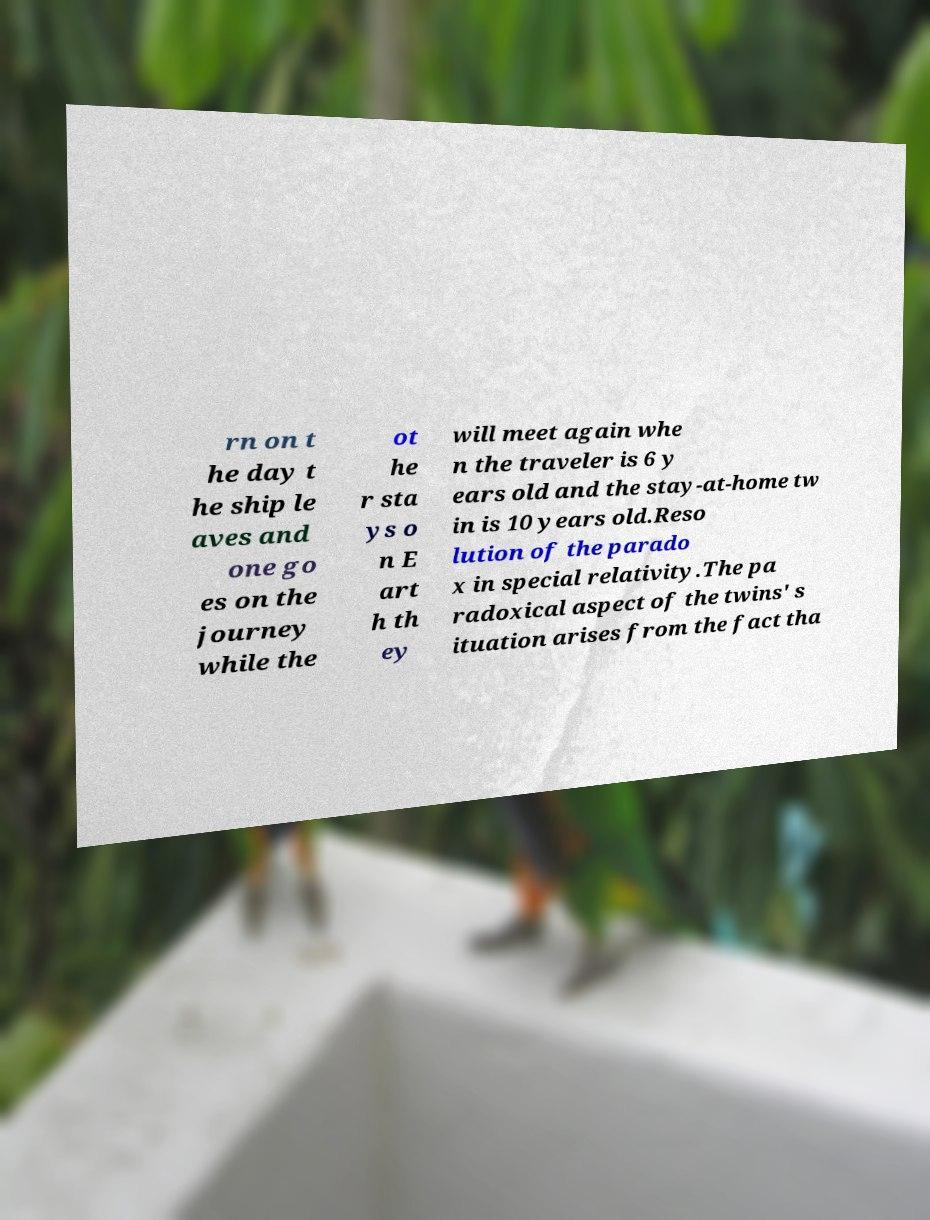Could you extract and type out the text from this image? rn on t he day t he ship le aves and one go es on the journey while the ot he r sta ys o n E art h th ey will meet again whe n the traveler is 6 y ears old and the stay-at-home tw in is 10 years old.Reso lution of the parado x in special relativity.The pa radoxical aspect of the twins' s ituation arises from the fact tha 